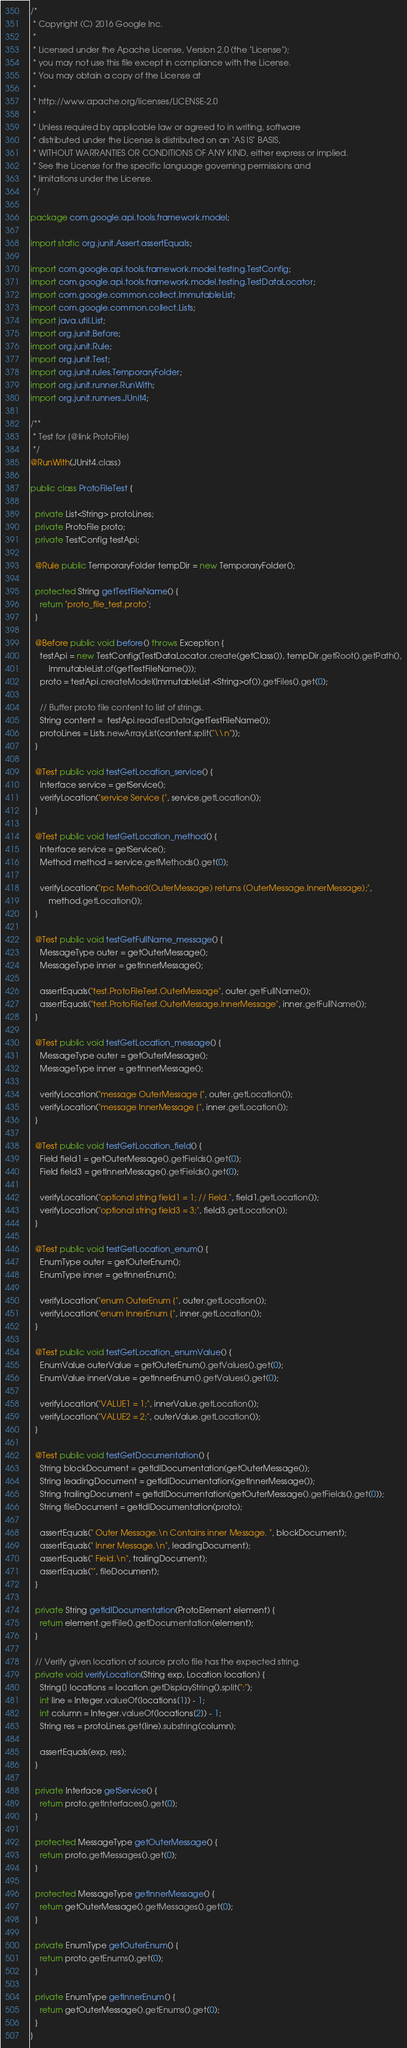<code> <loc_0><loc_0><loc_500><loc_500><_Java_>/*
 * Copyright (C) 2016 Google Inc.
 *
 * Licensed under the Apache License, Version 2.0 (the "License");
 * you may not use this file except in compliance with the License.
 * You may obtain a copy of the License at
 *
 * http://www.apache.org/licenses/LICENSE-2.0
 *
 * Unless required by applicable law or agreed to in writing, software
 * distributed under the License is distributed on an "AS IS" BASIS,
 * WITHOUT WARRANTIES OR CONDITIONS OF ANY KIND, either express or implied.
 * See the License for the specific language governing permissions and
 * limitations under the License.
 */

package com.google.api.tools.framework.model;

import static org.junit.Assert.assertEquals;

import com.google.api.tools.framework.model.testing.TestConfig;
import com.google.api.tools.framework.model.testing.TestDataLocator;
import com.google.common.collect.ImmutableList;
import com.google.common.collect.Lists;
import java.util.List;
import org.junit.Before;
import org.junit.Rule;
import org.junit.Test;
import org.junit.rules.TemporaryFolder;
import org.junit.runner.RunWith;
import org.junit.runners.JUnit4;

/**
 * Test for {@link ProtoFile}
 */
@RunWith(JUnit4.class)

public class ProtoFileTest {

  private List<String> protoLines;
  private ProtoFile proto;
  private TestConfig testApi;

  @Rule public TemporaryFolder tempDir = new TemporaryFolder();

  protected String getTestFileName() {
    return "proto_file_test.proto";
  }

  @Before public void before() throws Exception {
    testApi = new TestConfig(TestDataLocator.create(getClass()), tempDir.getRoot().getPath(),
        ImmutableList.of(getTestFileName()));
    proto = testApi.createModel(ImmutableList.<String>of()).getFiles().get(0);

    // Buffer proto file content to list of strings.
    String content =  testApi.readTestData(getTestFileName());
    protoLines = Lists.newArrayList(content.split("\\n"));
  }

  @Test public void testGetLocation_service() {
    Interface service = getService();
    verifyLocation("service Service {", service.getLocation());
  }

  @Test public void testGetLocation_method() {
    Interface service = getService();
    Method method = service.getMethods().get(0);

    verifyLocation("rpc Method(OuterMessage) returns (OuterMessage.InnerMessage);",
        method.getLocation());
  }

  @Test public void testGetFullName_message() {
    MessageType outer = getOuterMessage();
    MessageType inner = getInnerMessage();

    assertEquals("test.ProtoFileTest.OuterMessage", outer.getFullName());
    assertEquals("test.ProtoFileTest.OuterMessage.InnerMessage", inner.getFullName());
  }

  @Test public void testGetLocation_message() {
    MessageType outer = getOuterMessage();
    MessageType inner = getInnerMessage();

    verifyLocation("message OuterMessage {", outer.getLocation());
    verifyLocation("message InnerMessage {", inner.getLocation());
  }

  @Test public void testGetLocation_field() {
    Field field1 = getOuterMessage().getFields().get(0);
    Field field3 = getInnerMessage().getFields().get(0);

    verifyLocation("optional string field1 = 1; // Field.", field1.getLocation());
    verifyLocation("optional string field3 = 3;", field3.getLocation());
  }

  @Test public void testGetLocation_enum() {
    EnumType outer = getOuterEnum();
    EnumType inner = getInnerEnum();

    verifyLocation("enum OuterEnum {", outer.getLocation());
    verifyLocation("enum InnerEnum {", inner.getLocation());
  }

  @Test public void testGetLocation_enumValue() {
    EnumValue outerValue = getOuterEnum().getValues().get(0);
    EnumValue innerValue = getInnerEnum().getValues().get(0);

    verifyLocation("VALUE1 = 1;", innerValue.getLocation());
    verifyLocation("VALUE2 = 2;", outerValue.getLocation());
  }

  @Test public void testGetDocumentation() {
    String blockDocument = getIdlDocumentation(getOuterMessage());
    String leadingDocument = getIdlDocumentation(getInnerMessage());
    String trailingDocument = getIdlDocumentation(getOuterMessage().getFields().get(0));
    String fileDocument = getIdlDocumentation(proto);

    assertEquals(" Outer Message.\n Contains inner Message. ", blockDocument);
    assertEquals(" Inner Message.\n", leadingDocument);
    assertEquals(" Field.\n", trailingDocument);
    assertEquals("", fileDocument);
  }

  private String getIdlDocumentation(ProtoElement element) {
    return element.getFile().getDocumentation(element);
  }

  // Verify given location of source proto file has the expected string.
  private void verifyLocation(String exp, Location location) {
    String[] locations = location.getDisplayString().split(":");
    int line = Integer.valueOf(locations[1]) - 1;
    int column = Integer.valueOf(locations[2]) - 1;
    String res = protoLines.get(line).substring(column);

    assertEquals(exp, res);
  }

  private Interface getService() {
    return proto.getInterfaces().get(0);
  }

  protected MessageType getOuterMessage() {
    return proto.getMessages().get(0);
  }

  protected MessageType getInnerMessage() {
    return getOuterMessage().getMessages().get(0);
  }

  private EnumType getOuterEnum() {
    return proto.getEnums().get(0);
  }

  private EnumType getInnerEnum() {
    return getOuterMessage().getEnums().get(0);
  }
}
</code> 